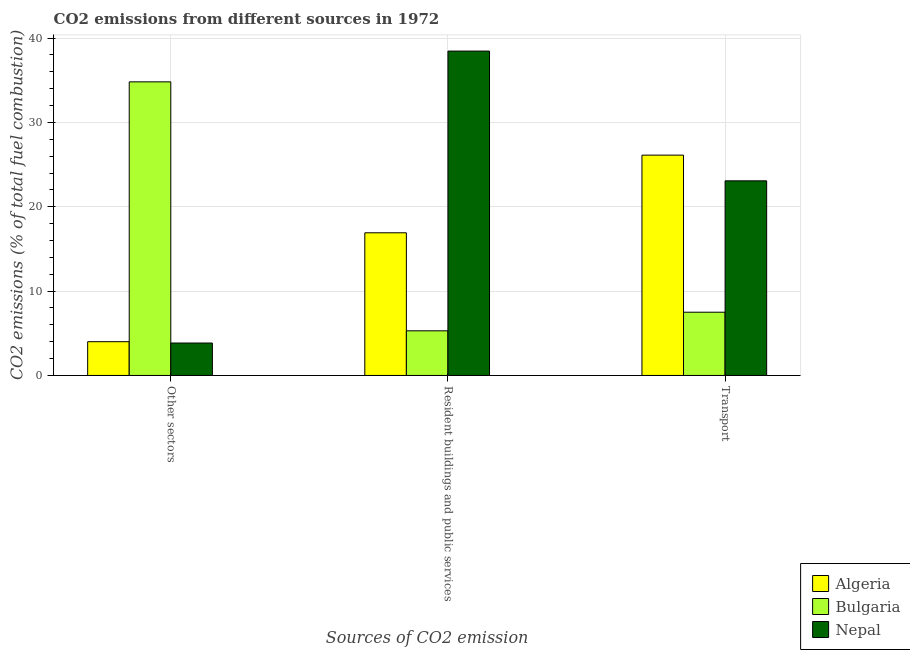How many groups of bars are there?
Your response must be concise. 3. Are the number of bars per tick equal to the number of legend labels?
Give a very brief answer. Yes. Are the number of bars on each tick of the X-axis equal?
Your response must be concise. Yes. How many bars are there on the 1st tick from the right?
Offer a terse response. 3. What is the label of the 2nd group of bars from the left?
Make the answer very short. Resident buildings and public services. What is the percentage of co2 emissions from transport in Algeria?
Offer a terse response. 26.13. Across all countries, what is the maximum percentage of co2 emissions from other sectors?
Your response must be concise. 34.81. In which country was the percentage of co2 emissions from resident buildings and public services maximum?
Offer a terse response. Nepal. What is the total percentage of co2 emissions from transport in the graph?
Make the answer very short. 56.7. What is the difference between the percentage of co2 emissions from other sectors in Algeria and that in Bulgaria?
Provide a short and direct response. -30.81. What is the difference between the percentage of co2 emissions from transport in Nepal and the percentage of co2 emissions from other sectors in Bulgaria?
Offer a terse response. -11.74. What is the average percentage of co2 emissions from other sectors per country?
Ensure brevity in your answer.  14.22. What is the difference between the percentage of co2 emissions from resident buildings and public services and percentage of co2 emissions from transport in Bulgaria?
Your response must be concise. -2.21. What is the ratio of the percentage of co2 emissions from resident buildings and public services in Bulgaria to that in Algeria?
Make the answer very short. 0.31. What is the difference between the highest and the second highest percentage of co2 emissions from transport?
Ensure brevity in your answer.  3.05. What is the difference between the highest and the lowest percentage of co2 emissions from other sectors?
Provide a succinct answer. 30.97. In how many countries, is the percentage of co2 emissions from resident buildings and public services greater than the average percentage of co2 emissions from resident buildings and public services taken over all countries?
Your answer should be compact. 1. Is the sum of the percentage of co2 emissions from resident buildings and public services in Bulgaria and Nepal greater than the maximum percentage of co2 emissions from other sectors across all countries?
Give a very brief answer. Yes. What does the 1st bar from the left in Transport represents?
Provide a succinct answer. Algeria. What does the 1st bar from the right in Resident buildings and public services represents?
Your response must be concise. Nepal. What is the difference between two consecutive major ticks on the Y-axis?
Your answer should be compact. 10. Are the values on the major ticks of Y-axis written in scientific E-notation?
Keep it short and to the point. No. Does the graph contain any zero values?
Offer a terse response. No. Does the graph contain grids?
Provide a short and direct response. Yes. Where does the legend appear in the graph?
Offer a terse response. Bottom right. How are the legend labels stacked?
Offer a terse response. Vertical. What is the title of the graph?
Provide a succinct answer. CO2 emissions from different sources in 1972. Does "South Africa" appear as one of the legend labels in the graph?
Provide a succinct answer. No. What is the label or title of the X-axis?
Keep it short and to the point. Sources of CO2 emission. What is the label or title of the Y-axis?
Offer a terse response. CO2 emissions (% of total fuel combustion). What is the CO2 emissions (% of total fuel combustion) of Algeria in Other sectors?
Your response must be concise. 4. What is the CO2 emissions (% of total fuel combustion) of Bulgaria in Other sectors?
Give a very brief answer. 34.81. What is the CO2 emissions (% of total fuel combustion) of Nepal in Other sectors?
Your answer should be compact. 3.85. What is the CO2 emissions (% of total fuel combustion) in Algeria in Resident buildings and public services?
Provide a succinct answer. 16.92. What is the CO2 emissions (% of total fuel combustion) of Bulgaria in Resident buildings and public services?
Ensure brevity in your answer.  5.29. What is the CO2 emissions (% of total fuel combustion) of Nepal in Resident buildings and public services?
Your answer should be very brief. 38.46. What is the CO2 emissions (% of total fuel combustion) of Algeria in Transport?
Ensure brevity in your answer.  26.13. What is the CO2 emissions (% of total fuel combustion) of Bulgaria in Transport?
Ensure brevity in your answer.  7.5. What is the CO2 emissions (% of total fuel combustion) in Nepal in Transport?
Offer a very short reply. 23.08. Across all Sources of CO2 emission, what is the maximum CO2 emissions (% of total fuel combustion) of Algeria?
Your response must be concise. 26.13. Across all Sources of CO2 emission, what is the maximum CO2 emissions (% of total fuel combustion) in Bulgaria?
Make the answer very short. 34.81. Across all Sources of CO2 emission, what is the maximum CO2 emissions (% of total fuel combustion) in Nepal?
Your response must be concise. 38.46. Across all Sources of CO2 emission, what is the minimum CO2 emissions (% of total fuel combustion) of Algeria?
Offer a very short reply. 4. Across all Sources of CO2 emission, what is the minimum CO2 emissions (% of total fuel combustion) of Bulgaria?
Make the answer very short. 5.29. Across all Sources of CO2 emission, what is the minimum CO2 emissions (% of total fuel combustion) in Nepal?
Keep it short and to the point. 3.85. What is the total CO2 emissions (% of total fuel combustion) in Algeria in the graph?
Offer a very short reply. 47.05. What is the total CO2 emissions (% of total fuel combustion) of Bulgaria in the graph?
Make the answer very short. 47.61. What is the total CO2 emissions (% of total fuel combustion) in Nepal in the graph?
Keep it short and to the point. 65.38. What is the difference between the CO2 emissions (% of total fuel combustion) of Algeria in Other sectors and that in Resident buildings and public services?
Your answer should be very brief. -12.91. What is the difference between the CO2 emissions (% of total fuel combustion) of Bulgaria in Other sectors and that in Resident buildings and public services?
Make the answer very short. 29.52. What is the difference between the CO2 emissions (% of total fuel combustion) in Nepal in Other sectors and that in Resident buildings and public services?
Offer a terse response. -34.62. What is the difference between the CO2 emissions (% of total fuel combustion) of Algeria in Other sectors and that in Transport?
Give a very brief answer. -22.12. What is the difference between the CO2 emissions (% of total fuel combustion) of Bulgaria in Other sectors and that in Transport?
Your answer should be very brief. 27.31. What is the difference between the CO2 emissions (% of total fuel combustion) of Nepal in Other sectors and that in Transport?
Your answer should be compact. -19.23. What is the difference between the CO2 emissions (% of total fuel combustion) of Algeria in Resident buildings and public services and that in Transport?
Provide a short and direct response. -9.21. What is the difference between the CO2 emissions (% of total fuel combustion) of Bulgaria in Resident buildings and public services and that in Transport?
Your response must be concise. -2.21. What is the difference between the CO2 emissions (% of total fuel combustion) in Nepal in Resident buildings and public services and that in Transport?
Offer a very short reply. 15.38. What is the difference between the CO2 emissions (% of total fuel combustion) in Algeria in Other sectors and the CO2 emissions (% of total fuel combustion) in Bulgaria in Resident buildings and public services?
Provide a succinct answer. -1.29. What is the difference between the CO2 emissions (% of total fuel combustion) of Algeria in Other sectors and the CO2 emissions (% of total fuel combustion) of Nepal in Resident buildings and public services?
Ensure brevity in your answer.  -34.46. What is the difference between the CO2 emissions (% of total fuel combustion) in Bulgaria in Other sectors and the CO2 emissions (% of total fuel combustion) in Nepal in Resident buildings and public services?
Ensure brevity in your answer.  -3.65. What is the difference between the CO2 emissions (% of total fuel combustion) of Algeria in Other sectors and the CO2 emissions (% of total fuel combustion) of Bulgaria in Transport?
Provide a short and direct response. -3.5. What is the difference between the CO2 emissions (% of total fuel combustion) in Algeria in Other sectors and the CO2 emissions (% of total fuel combustion) in Nepal in Transport?
Offer a terse response. -19.07. What is the difference between the CO2 emissions (% of total fuel combustion) of Bulgaria in Other sectors and the CO2 emissions (% of total fuel combustion) of Nepal in Transport?
Keep it short and to the point. 11.74. What is the difference between the CO2 emissions (% of total fuel combustion) of Algeria in Resident buildings and public services and the CO2 emissions (% of total fuel combustion) of Bulgaria in Transport?
Your answer should be compact. 9.42. What is the difference between the CO2 emissions (% of total fuel combustion) in Algeria in Resident buildings and public services and the CO2 emissions (% of total fuel combustion) in Nepal in Transport?
Your response must be concise. -6.16. What is the difference between the CO2 emissions (% of total fuel combustion) in Bulgaria in Resident buildings and public services and the CO2 emissions (% of total fuel combustion) in Nepal in Transport?
Provide a succinct answer. -17.78. What is the average CO2 emissions (% of total fuel combustion) of Algeria per Sources of CO2 emission?
Ensure brevity in your answer.  15.68. What is the average CO2 emissions (% of total fuel combustion) in Bulgaria per Sources of CO2 emission?
Give a very brief answer. 15.87. What is the average CO2 emissions (% of total fuel combustion) of Nepal per Sources of CO2 emission?
Ensure brevity in your answer.  21.79. What is the difference between the CO2 emissions (% of total fuel combustion) of Algeria and CO2 emissions (% of total fuel combustion) of Bulgaria in Other sectors?
Offer a very short reply. -30.81. What is the difference between the CO2 emissions (% of total fuel combustion) of Algeria and CO2 emissions (% of total fuel combustion) of Nepal in Other sectors?
Keep it short and to the point. 0.16. What is the difference between the CO2 emissions (% of total fuel combustion) of Bulgaria and CO2 emissions (% of total fuel combustion) of Nepal in Other sectors?
Keep it short and to the point. 30.97. What is the difference between the CO2 emissions (% of total fuel combustion) of Algeria and CO2 emissions (% of total fuel combustion) of Bulgaria in Resident buildings and public services?
Provide a short and direct response. 11.62. What is the difference between the CO2 emissions (% of total fuel combustion) in Algeria and CO2 emissions (% of total fuel combustion) in Nepal in Resident buildings and public services?
Offer a terse response. -21.54. What is the difference between the CO2 emissions (% of total fuel combustion) of Bulgaria and CO2 emissions (% of total fuel combustion) of Nepal in Resident buildings and public services?
Provide a succinct answer. -33.17. What is the difference between the CO2 emissions (% of total fuel combustion) in Algeria and CO2 emissions (% of total fuel combustion) in Bulgaria in Transport?
Give a very brief answer. 18.63. What is the difference between the CO2 emissions (% of total fuel combustion) in Algeria and CO2 emissions (% of total fuel combustion) in Nepal in Transport?
Ensure brevity in your answer.  3.05. What is the difference between the CO2 emissions (% of total fuel combustion) in Bulgaria and CO2 emissions (% of total fuel combustion) in Nepal in Transport?
Make the answer very short. -15.58. What is the ratio of the CO2 emissions (% of total fuel combustion) of Algeria in Other sectors to that in Resident buildings and public services?
Make the answer very short. 0.24. What is the ratio of the CO2 emissions (% of total fuel combustion) in Bulgaria in Other sectors to that in Resident buildings and public services?
Your answer should be very brief. 6.58. What is the ratio of the CO2 emissions (% of total fuel combustion) in Nepal in Other sectors to that in Resident buildings and public services?
Offer a terse response. 0.1. What is the ratio of the CO2 emissions (% of total fuel combustion) in Algeria in Other sectors to that in Transport?
Make the answer very short. 0.15. What is the ratio of the CO2 emissions (% of total fuel combustion) of Bulgaria in Other sectors to that in Transport?
Keep it short and to the point. 4.64. What is the ratio of the CO2 emissions (% of total fuel combustion) of Algeria in Resident buildings and public services to that in Transport?
Provide a succinct answer. 0.65. What is the ratio of the CO2 emissions (% of total fuel combustion) in Bulgaria in Resident buildings and public services to that in Transport?
Make the answer very short. 0.71. What is the ratio of the CO2 emissions (% of total fuel combustion) of Nepal in Resident buildings and public services to that in Transport?
Give a very brief answer. 1.67. What is the difference between the highest and the second highest CO2 emissions (% of total fuel combustion) in Algeria?
Your answer should be very brief. 9.21. What is the difference between the highest and the second highest CO2 emissions (% of total fuel combustion) of Bulgaria?
Offer a terse response. 27.31. What is the difference between the highest and the second highest CO2 emissions (% of total fuel combustion) of Nepal?
Provide a succinct answer. 15.38. What is the difference between the highest and the lowest CO2 emissions (% of total fuel combustion) in Algeria?
Offer a very short reply. 22.12. What is the difference between the highest and the lowest CO2 emissions (% of total fuel combustion) of Bulgaria?
Your answer should be compact. 29.52. What is the difference between the highest and the lowest CO2 emissions (% of total fuel combustion) of Nepal?
Ensure brevity in your answer.  34.62. 